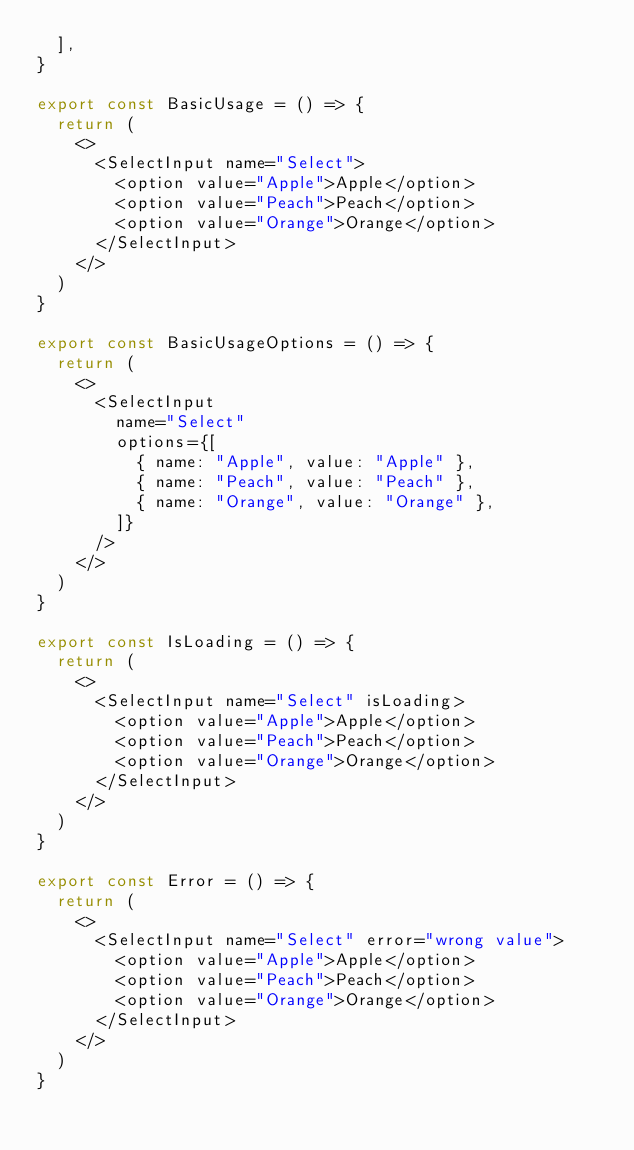Convert code to text. <code><loc_0><loc_0><loc_500><loc_500><_TypeScript_>  ],
}

export const BasicUsage = () => {
  return (
    <>
      <SelectInput name="Select">
        <option value="Apple">Apple</option>
        <option value="Peach">Peach</option>
        <option value="Orange">Orange</option>
      </SelectInput>
    </>
  )
}

export const BasicUsageOptions = () => {
  return (
    <>
      <SelectInput
        name="Select"
        options={[
          { name: "Apple", value: "Apple" },
          { name: "Peach", value: "Peach" },
          { name: "Orange", value: "Orange" },
        ]}
      />
    </>
  )
}

export const IsLoading = () => {
  return (
    <>
      <SelectInput name="Select" isLoading>
        <option value="Apple">Apple</option>
        <option value="Peach">Peach</option>
        <option value="Orange">Orange</option>
      </SelectInput>
    </>
  )
}

export const Error = () => {
  return (
    <>
      <SelectInput name="Select" error="wrong value">
        <option value="Apple">Apple</option>
        <option value="Peach">Peach</option>
        <option value="Orange">Orange</option>
      </SelectInput>
    </>
  )
}
</code> 